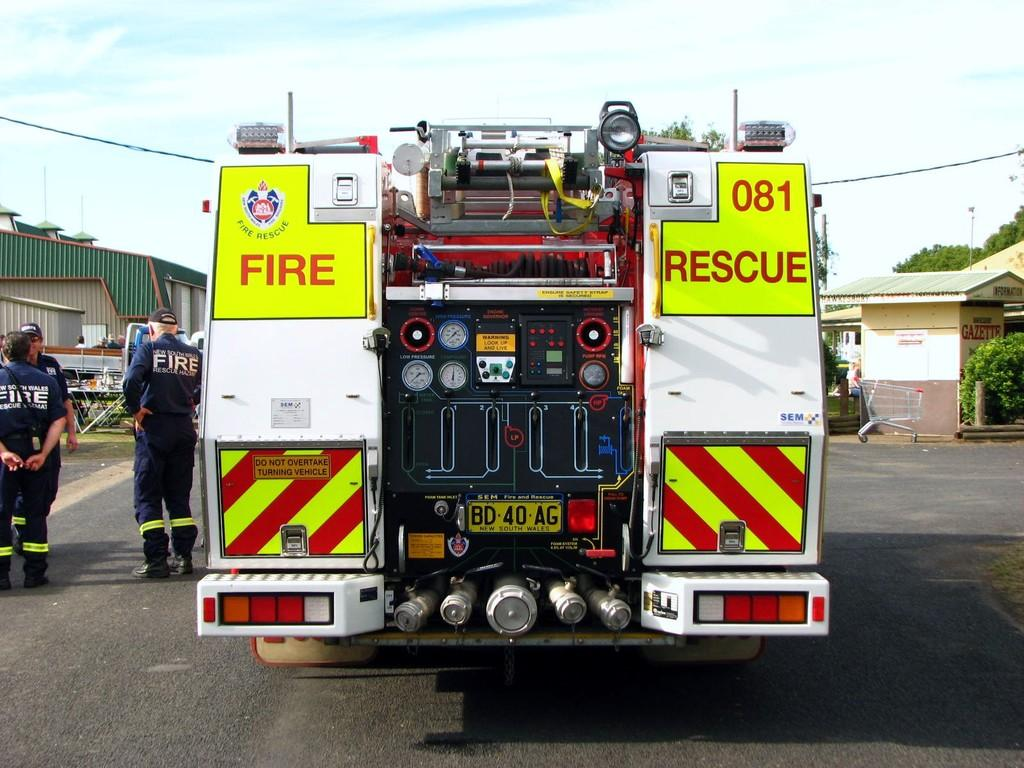What type of vehicle can be seen in the image? There is a vehicle in the image, but the specific type is not mentioned. What structures are present in the image? There are sheds and a pole in the image. What natural elements are visible in the image? There are trees and a cloudy sky in the image. What is the primary mode of transportation for the people in the image? The people are on the road, which suggests they are using the vehicle as their mode of transportation. How many objects can be identified in the image? There are objects in the image, but the exact number is not mentioned. What type of root can be seen growing from the vehicle in the image? There is no root growing from the vehicle in the image. Are the people in the image wearing masks? The image does not provide information about whether the people are wearing masks or not. 